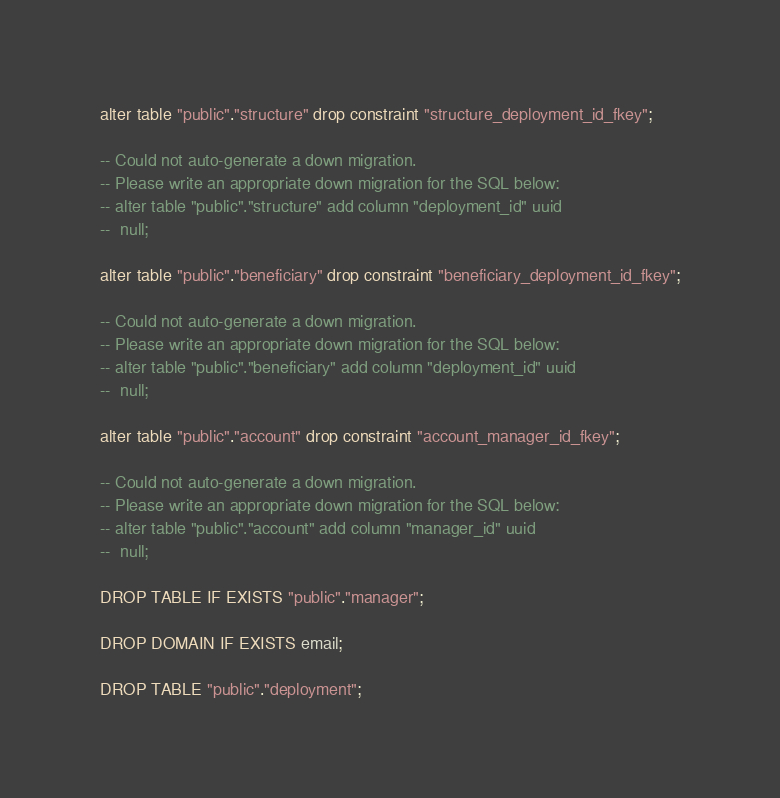<code> <loc_0><loc_0><loc_500><loc_500><_SQL_>
alter table "public"."structure" drop constraint "structure_deployment_id_fkey";

-- Could not auto-generate a down migration.
-- Please write an appropriate down migration for the SQL below:
-- alter table "public"."structure" add column "deployment_id" uuid
--  null;

alter table "public"."beneficiary" drop constraint "beneficiary_deployment_id_fkey";

-- Could not auto-generate a down migration.
-- Please write an appropriate down migration for the SQL below:
-- alter table "public"."beneficiary" add column "deployment_id" uuid
--  null;

alter table "public"."account" drop constraint "account_manager_id_fkey";

-- Could not auto-generate a down migration.
-- Please write an appropriate down migration for the SQL below:
-- alter table "public"."account" add column "manager_id" uuid
--  null;

DROP TABLE IF EXISTS "public"."manager";

DROP DOMAIN IF EXISTS email;

DROP TABLE "public"."deployment";
</code> 